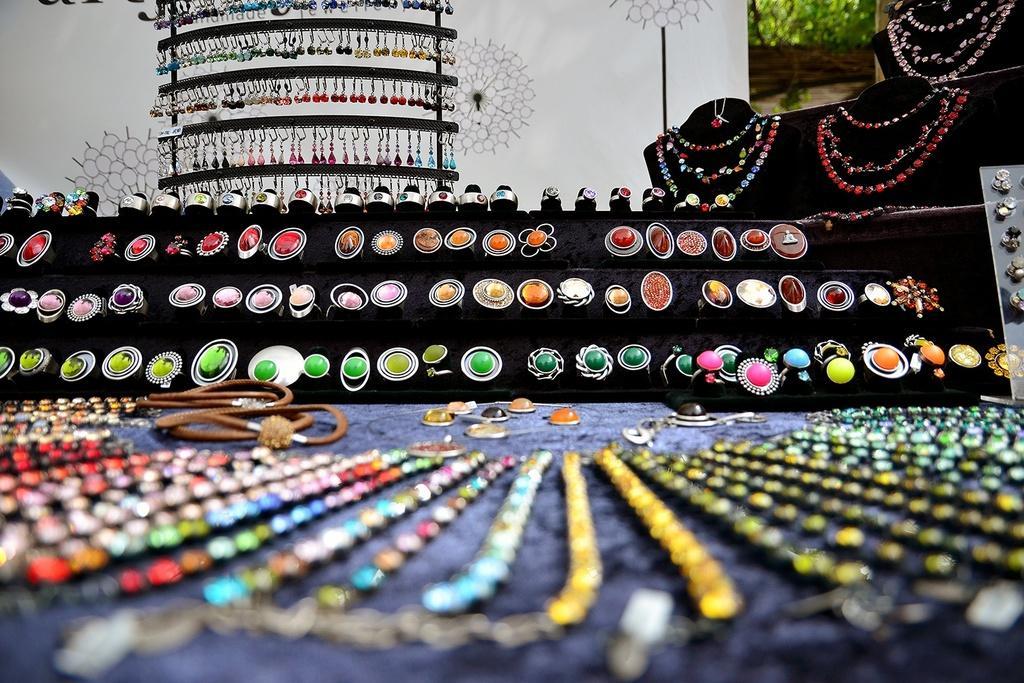Could you give a brief overview of what you see in this image? In this picture we can see ornaments and in the background we can see some objects. 